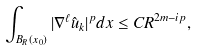Convert formula to latex. <formula><loc_0><loc_0><loc_500><loc_500>\int _ { B _ { R } ( x _ { 0 } ) } | \nabla ^ { \ell } \hat { u } _ { k } | ^ { p } d x \leq C R ^ { 2 m - i p } ,</formula> 